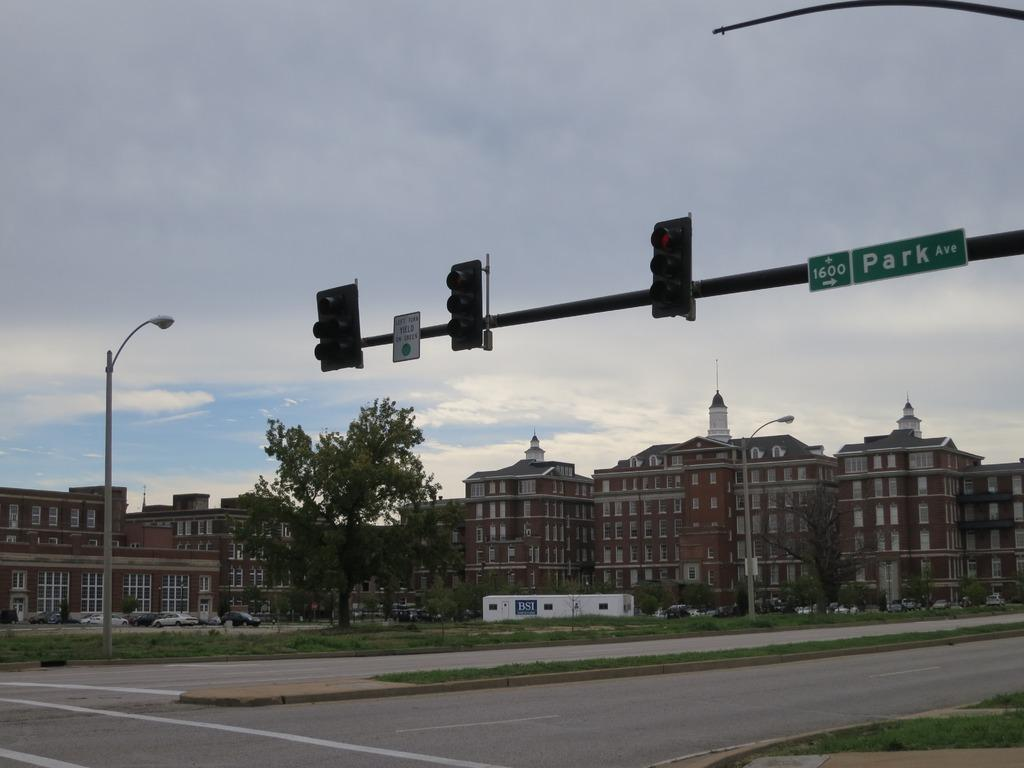Provide a one-sentence caption for the provided image. The intersection of 1600 Park Avenue has a lot of tall buildings nearby. 